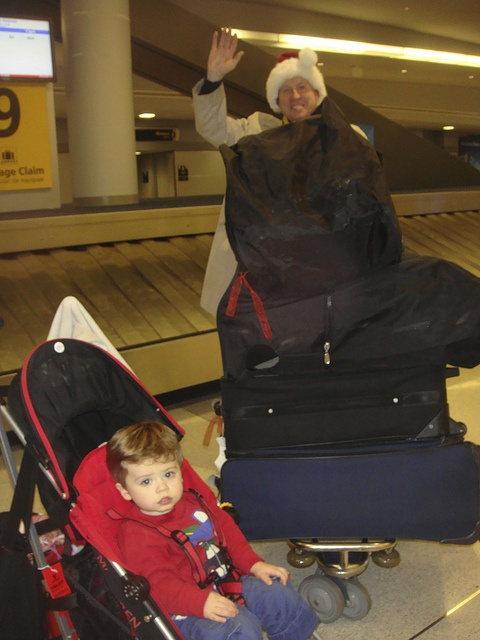Describe the objects in this image and their specific colors. I can see suitcase in black, maroon, gray, and olive tones, suitcase in black and gray tones, people in black, brown, gray, maroon, and tan tones, suitcase in black and gray tones, and people in black, gray, tan, maroon, and brown tones in this image. 